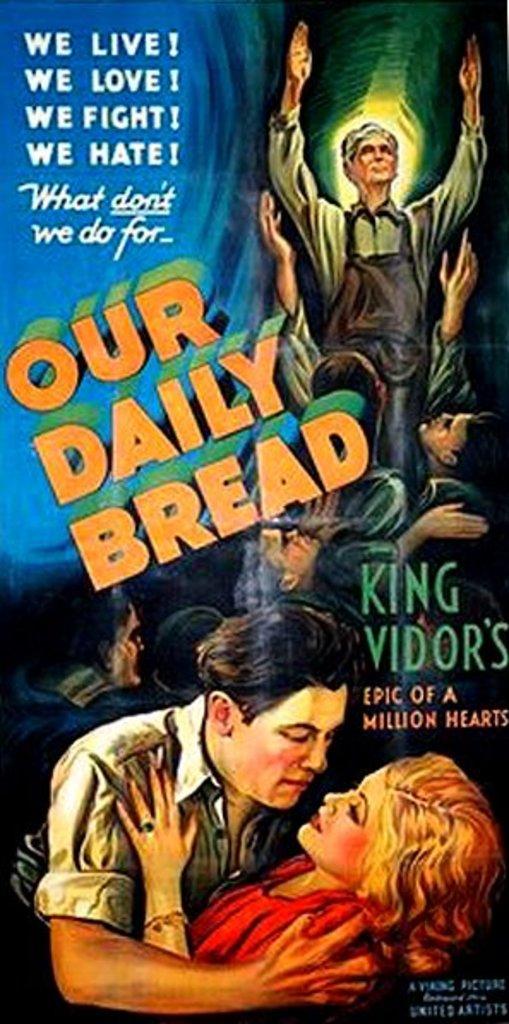What is this movie?
Keep it short and to the point. Our daily bread. Who wrote that show?
Make the answer very short. King vidor. 